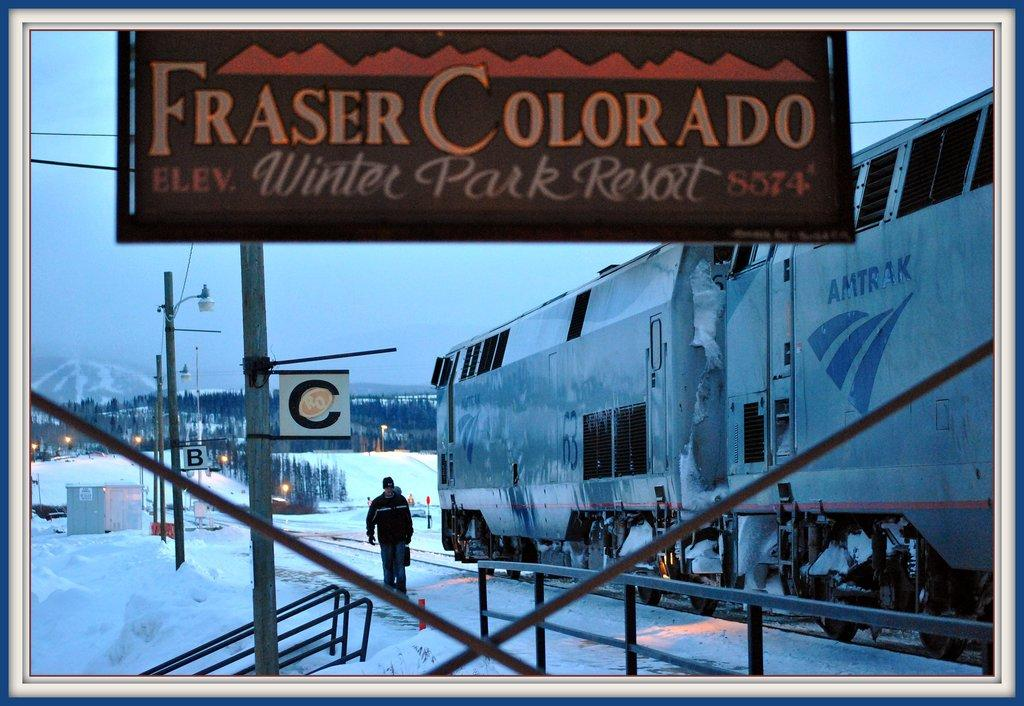<image>
Render a clear and concise summary of the photo. A sign next to a train that reads Fraser Colorado Winter Park Resort. 